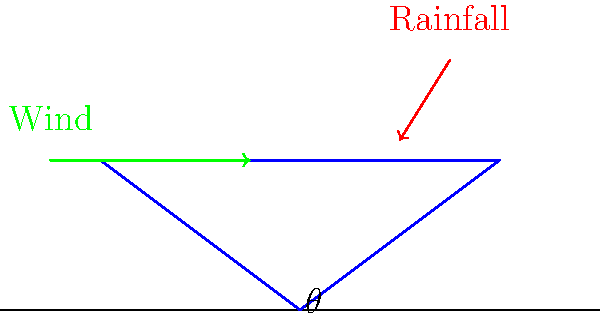As a science enthusiast interested in structural engineering, you're researching optimal roof designs for areas with high rainfall and strong winds. Based on the cross-section diagram provided, which shows a roof with angle $\theta$, rainfall direction, and wind direction, how would you determine the optimal angle $\theta$ to balance water runoff efficiency and wind resistance? To determine the optimal roof angle $\theta$, we need to consider both water runoff efficiency and wind resistance:

1. Water runoff efficiency:
   - A steeper angle increases runoff speed, reducing the risk of water accumulation.
   - The optimal angle for water runoff is typically between 30° and 45°.

2. Wind resistance:
   - A lower angle reduces wind uplift forces on the roof.
   - The optimal angle for wind resistance is usually less than 30°.

3. Balancing the two factors:
   - We need to find an angle that provides adequate water runoff while minimizing wind uplift.
   - This balance point is typically around 30°.

4. Additional considerations:
   - Local climate data: Analyze the average rainfall intensity and wind speeds in the area.
   - Wind direction: If prevailing winds are consistently from one direction, slight adjustments can be made.
   - Building codes: Ensure the chosen angle complies with local regulations.

5. Mathematical approach:
   - Water runoff efficiency can be modeled using the equation:
     $$E_w = k \sin(\theta)$$
     where $E_w$ is the water runoff efficiency and $k$ is a constant.
   - Wind uplift force can be modeled using:
     $$F_u = c \sin(\theta) \cos(\theta)$$
     where $F_u$ is the uplift force and $c$ is a constant dependent on wind speed.
   - The optimal angle can be found by maximizing the function:
     $$f(\theta) = E_w - F_u = k \sin(\theta) - c \sin(\theta) \cos(\theta)$$

6. Practical solution:
   - Start with a 30° angle as a baseline.
   - Adjust slightly based on local climate data and building codes.
   - Use computer simulations or wind tunnel tests for more precise optimization.
Answer: 30° with adjustments based on local climate data and building codes. 